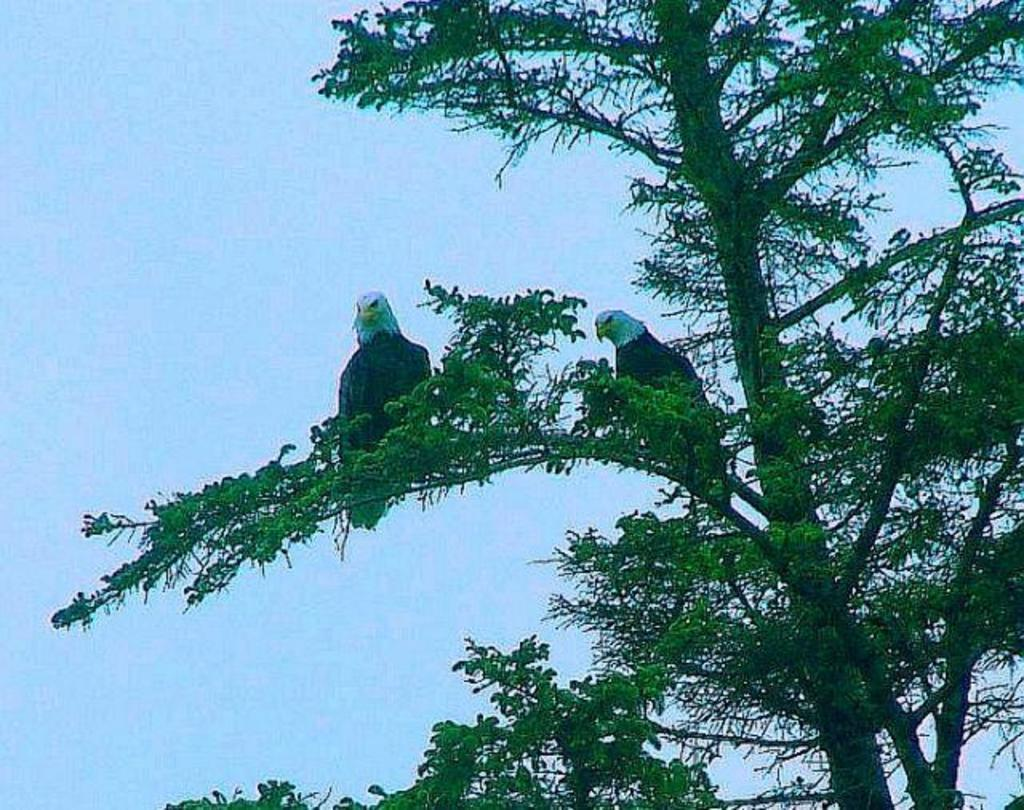What is located towards the right side of the image? There is a tree in the image, located towards the right. What can be seen on the tree? There are two birds on the tree. What is visible in the background of the image? The sky is visible in the background of the image. What color is the background of the image? The background of the image is blue in color. What type of insect can be seen thrilling the crowd in downtown in the image? There is no insect or crowd present in the image, nor is there any indication of a downtown location. 